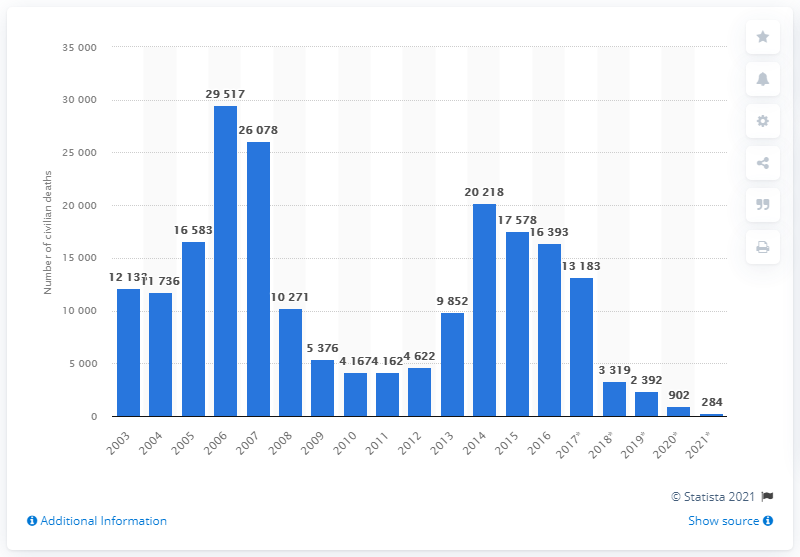Indicate a few pertinent items in this graphic. There were 284 civilian deaths in 2021. 